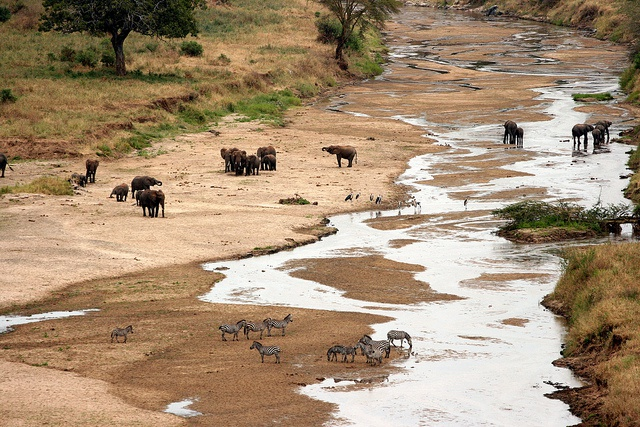Describe the objects in this image and their specific colors. I can see elephant in olive, black, maroon, gray, and brown tones, elephant in olive, black, gray, and tan tones, elephant in olive, black, maroon, and gray tones, zebra in olive, gray, and black tones, and zebra in olive, gray, and black tones in this image. 